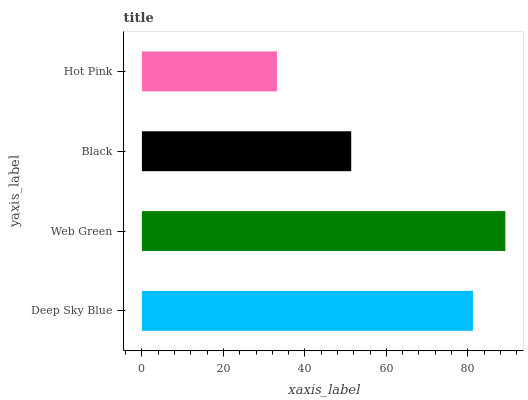Is Hot Pink the minimum?
Answer yes or no. Yes. Is Web Green the maximum?
Answer yes or no. Yes. Is Black the minimum?
Answer yes or no. No. Is Black the maximum?
Answer yes or no. No. Is Web Green greater than Black?
Answer yes or no. Yes. Is Black less than Web Green?
Answer yes or no. Yes. Is Black greater than Web Green?
Answer yes or no. No. Is Web Green less than Black?
Answer yes or no. No. Is Deep Sky Blue the high median?
Answer yes or no. Yes. Is Black the low median?
Answer yes or no. Yes. Is Web Green the high median?
Answer yes or no. No. Is Deep Sky Blue the low median?
Answer yes or no. No. 